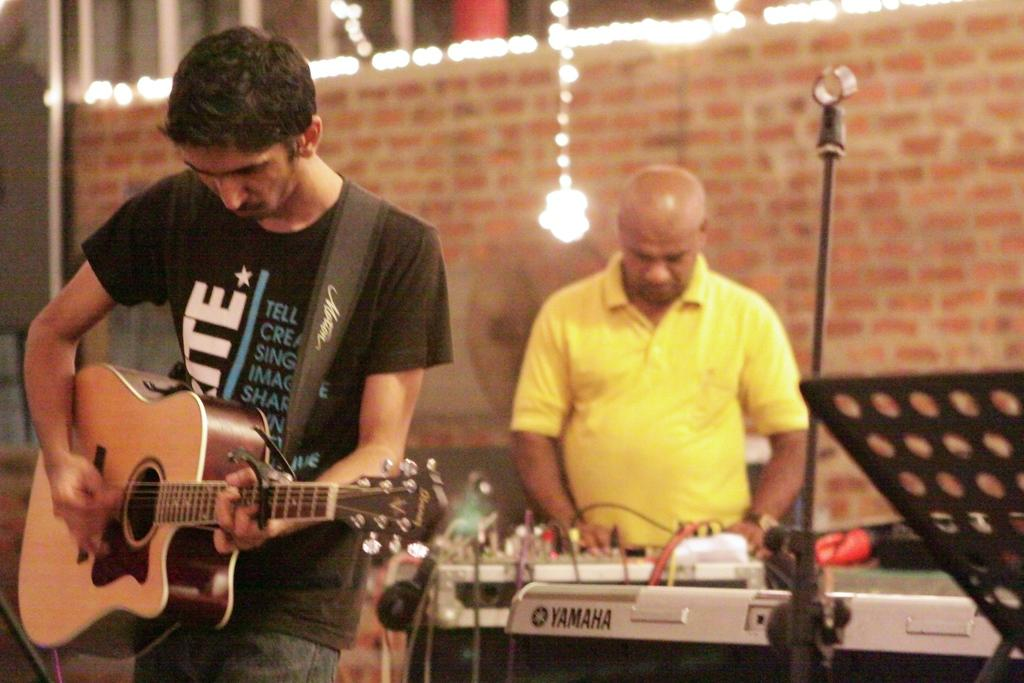How many people are in the image? There are two men in the image. What are the men doing in the image? Both men are playing musical instruments. What can be seen in the background of the image? There is a red wall and lights as decoration in the background of the image. What type of yarn is being used to play the musical instruments in the image? There is no yarn present in the image, and the musical instruments are not played with yarn. 